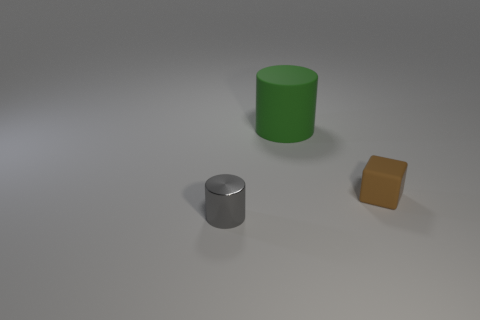Is there any other thing that is the same size as the green matte cylinder?
Keep it short and to the point. No. The gray object is what size?
Your answer should be compact. Small. What color is the thing that is the same size as the gray cylinder?
Ensure brevity in your answer.  Brown. Is there a tiny object that has the same color as the big object?
Your answer should be compact. No. What is the material of the gray cylinder?
Your answer should be very brief. Metal. How many tiny rubber blocks are there?
Ensure brevity in your answer.  1. There is a small thing that is in front of the tiny rubber thing; is its color the same as the small matte object on the right side of the big green object?
Make the answer very short. No. How many other things are there of the same size as the gray shiny thing?
Offer a terse response. 1. What color is the rubber thing behind the brown block?
Your response must be concise. Green. Does the cylinder that is left of the big cylinder have the same material as the cube?
Make the answer very short. No. 